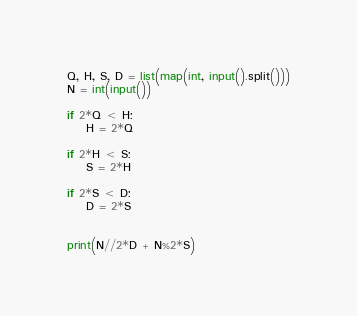<code> <loc_0><loc_0><loc_500><loc_500><_Python_>Q, H, S, D = list(map(int, input().split()))
N = int(input())

if 2*Q < H:
    H = 2*Q

if 2*H < S:
    S = 2*H

if 2*S < D:
    D = 2*S


print(N//2*D + N%2*S)
</code> 